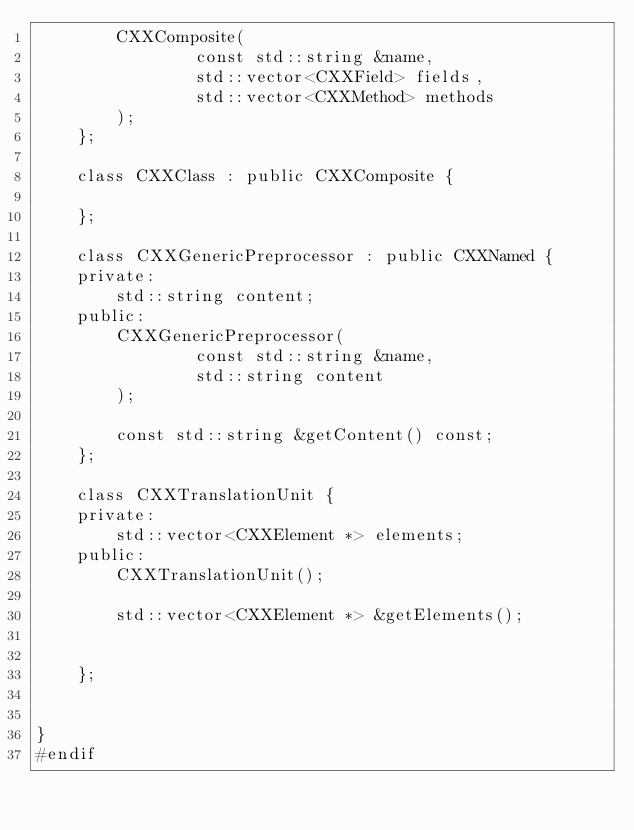Convert code to text. <code><loc_0><loc_0><loc_500><loc_500><_C_>        CXXComposite(
                const std::string &name,
                std::vector<CXXField> fields,
                std::vector<CXXMethod> methods
        );
    };

    class CXXClass : public CXXComposite {

    };

    class CXXGenericPreprocessor : public CXXNamed {
    private:
        std::string content;
    public:
        CXXGenericPreprocessor(
                const std::string &name,
                std::string content
        );

        const std::string &getContent() const;
    };

    class CXXTranslationUnit {
    private:
        std::vector<CXXElement *> elements;
    public:
        CXXTranslationUnit();

        std::vector<CXXElement *> &getElements();


    };


}
#endif
</code> 